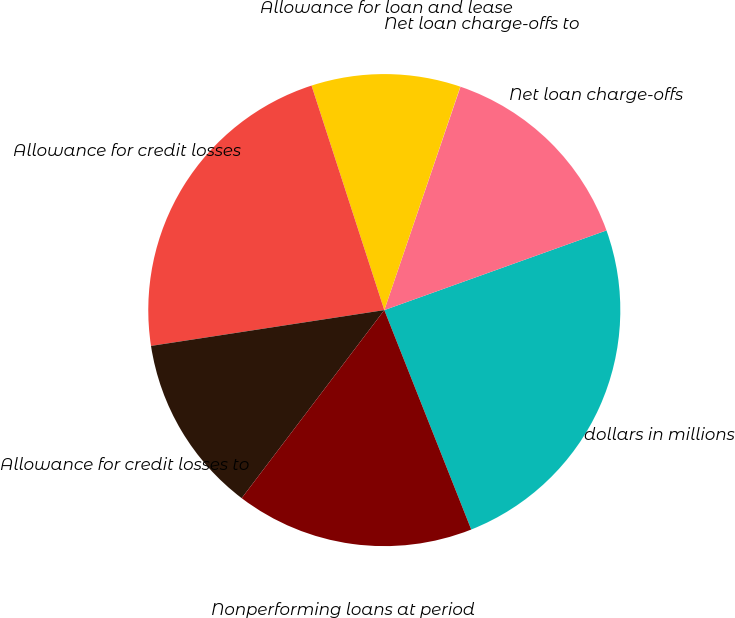Convert chart to OTSL. <chart><loc_0><loc_0><loc_500><loc_500><pie_chart><fcel>dollars in millions<fcel>Net loan charge-offs<fcel>Net loan charge-offs to<fcel>Allowance for loan and lease<fcel>Allowance for credit losses<fcel>Allowance for credit losses to<fcel>Nonperforming loans at period<nl><fcel>24.48%<fcel>14.29%<fcel>0.01%<fcel>10.21%<fcel>22.44%<fcel>12.25%<fcel>16.33%<nl></chart> 